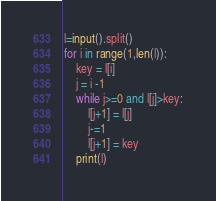Convert code to text. <code><loc_0><loc_0><loc_500><loc_500><_Python_>l=input().split()
for i in range(1,len(l)):
    key = l[i]
    j = i -1
    while j>=0 and l[j]>key:
        l[j+1] = l[j]
        j-=1
        l[j+1] = key
    print(l)
</code> 